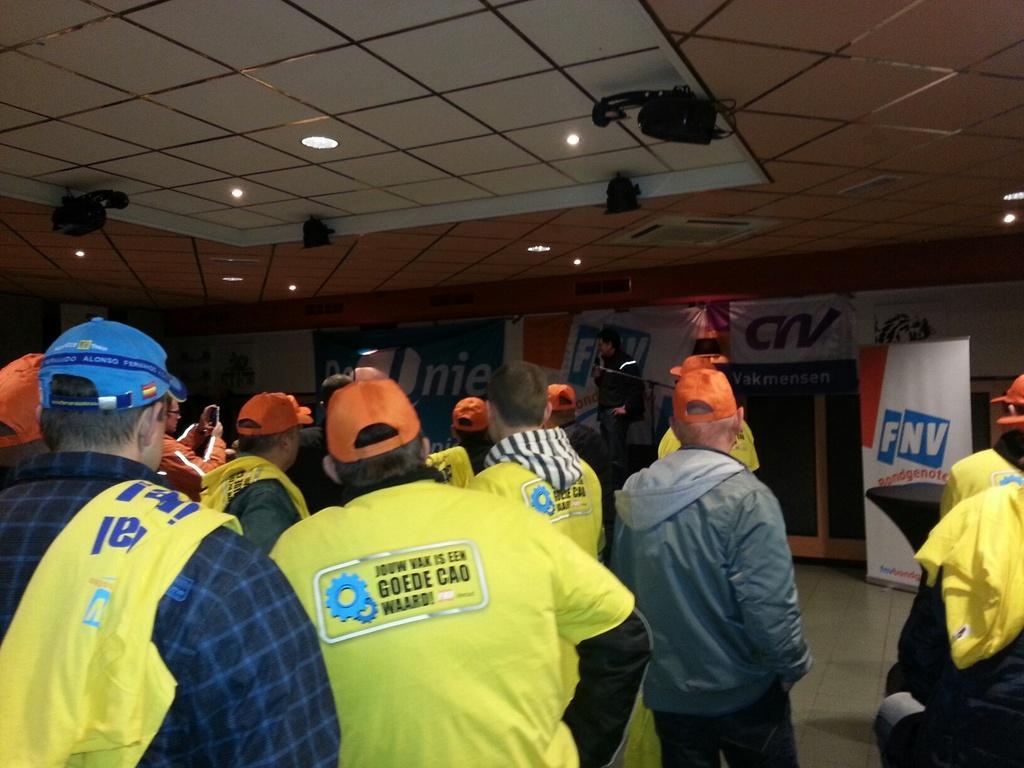Please provide a concise description of this image. In this image we can see some people and there is a person holding a mic in the background and we can see some posters with text. We can see the ceiling with lights and some other objects. 